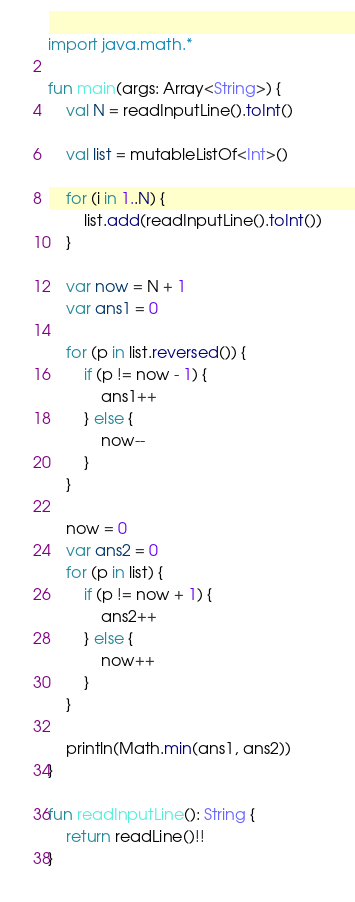Convert code to text. <code><loc_0><loc_0><loc_500><loc_500><_Kotlin_>import java.math.*

fun main(args: Array<String>) {
    val N = readInputLine().toInt()
    
    val list = mutableListOf<Int>()
    
    for (i in 1..N) {
        list.add(readInputLine().toInt())
    }
    
    var now = N + 1
    var ans1 = 0
    
    for (p in list.reversed()) {
        if (p != now - 1) {
            ans1++
        } else {
            now--
        }
    }
    
    now = 0
    var ans2 = 0
    for (p in list) {
        if (p != now + 1) {
            ans2++
        } else {
            now++
        }
    }

    println(Math.min(ans1, ans2))
}

fun readInputLine(): String {
    return readLine()!!
}
</code> 